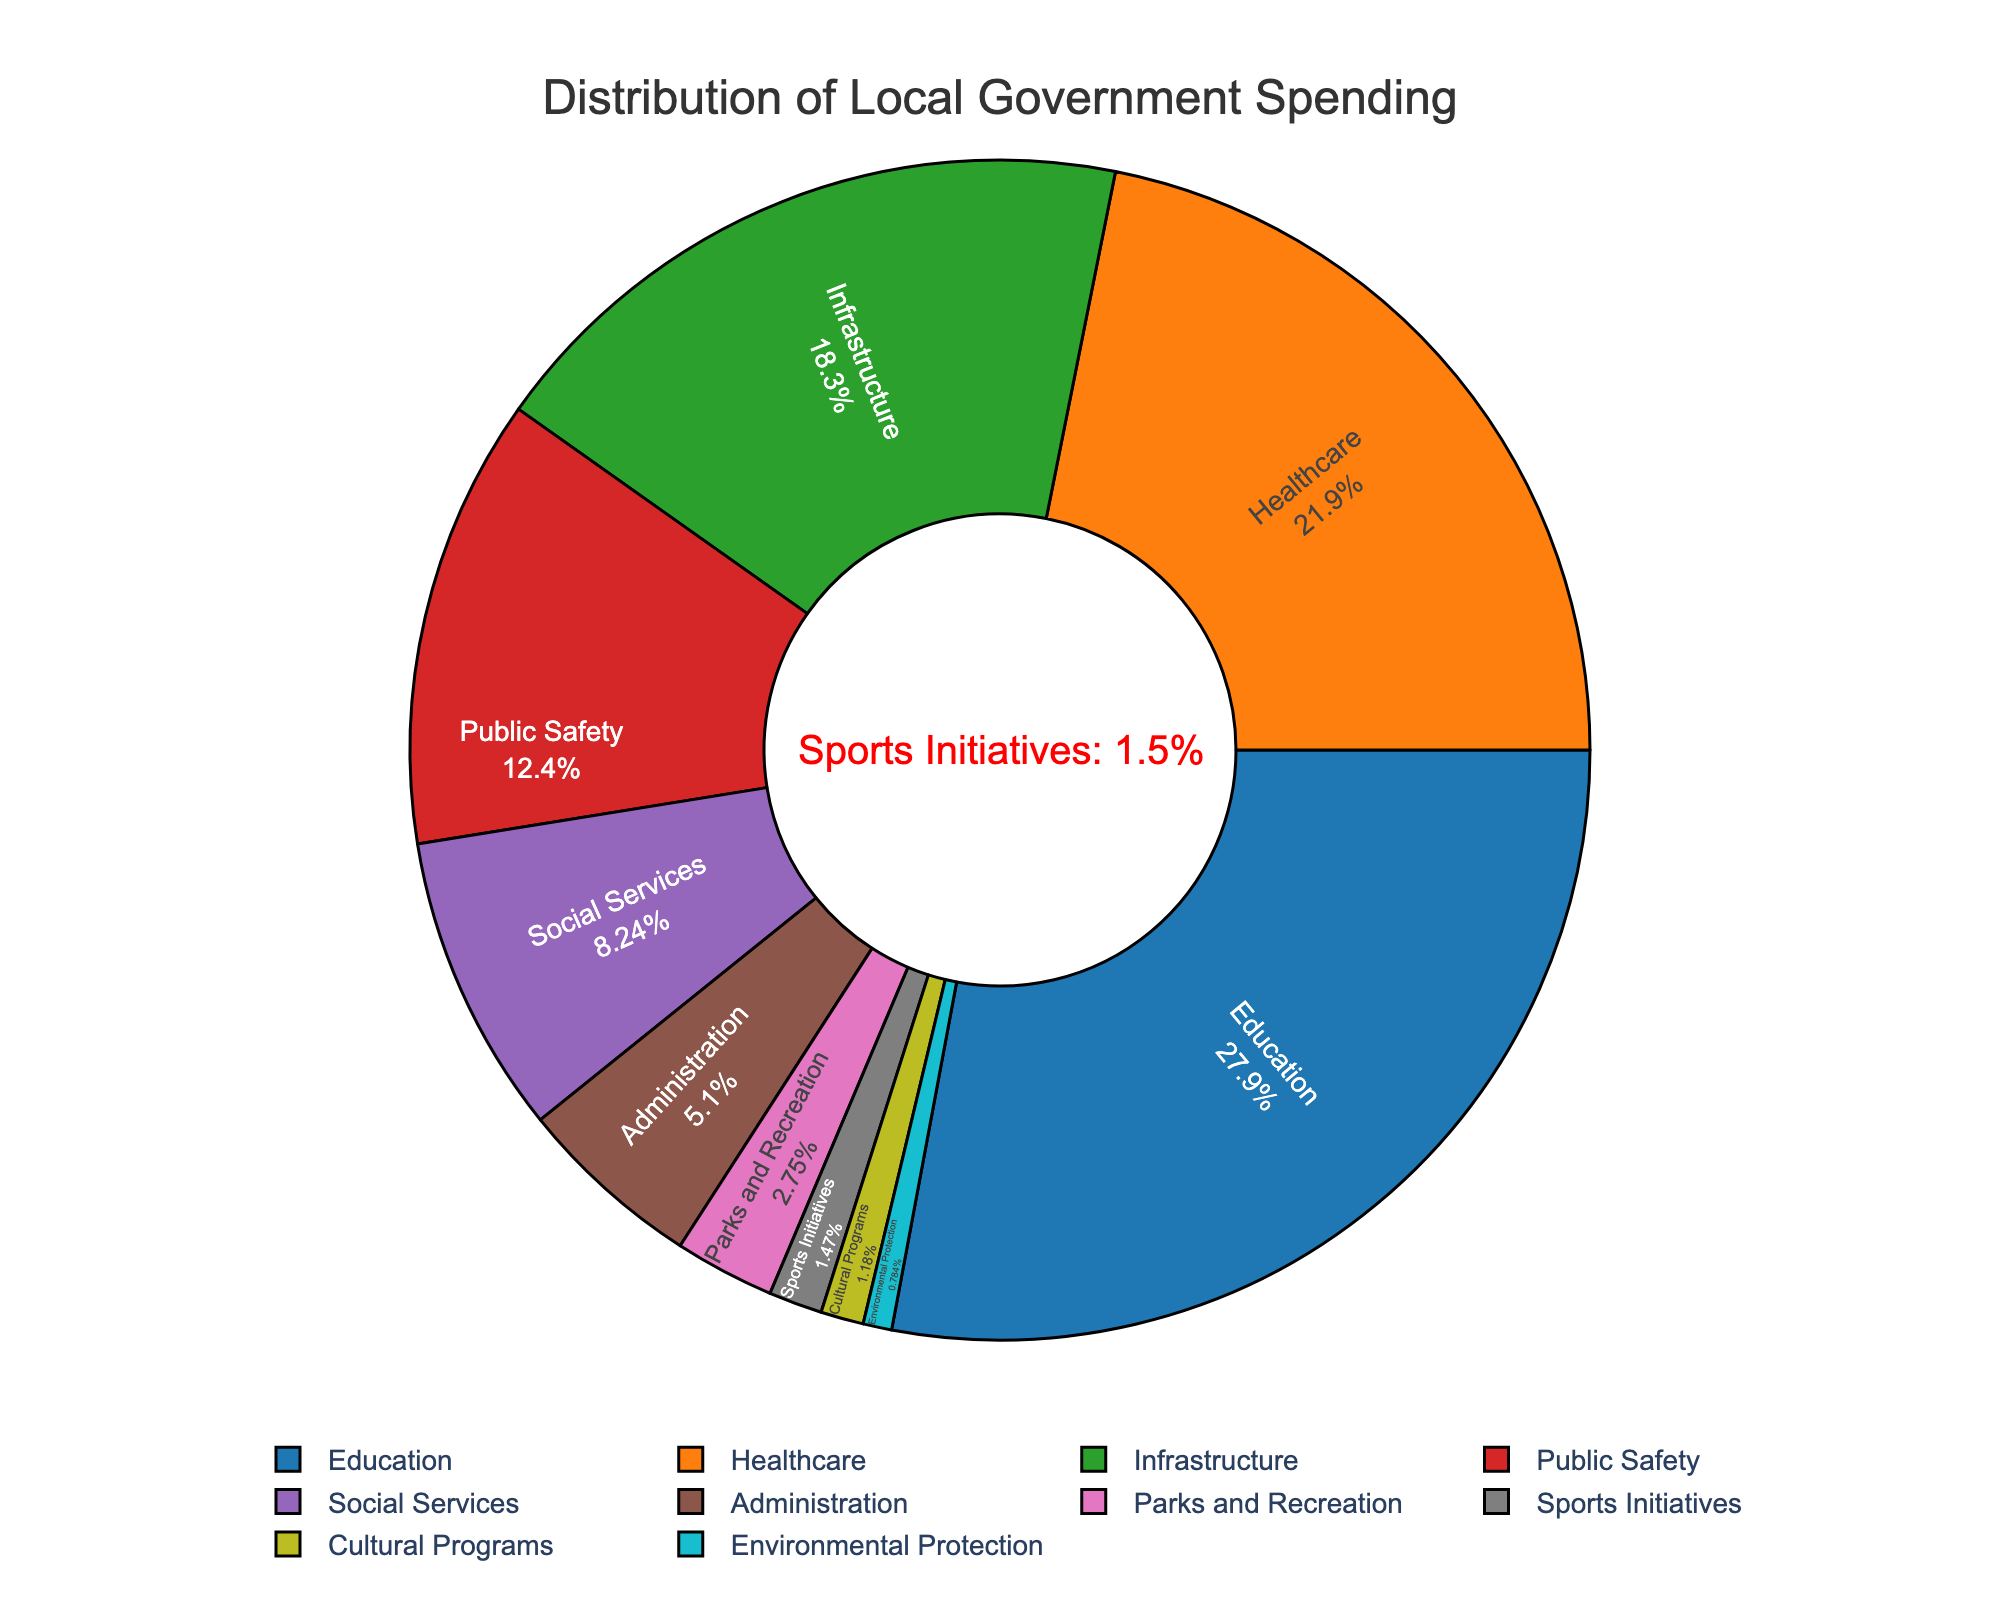What is the sector with the highest percentage of local government spending? The sector with the highest percentage can be identified by looking for the largest slice in the pie chart. Here, 'Education' has the largest slice with 28.5%.
Answer: Education (28.5%) What is the total percentage of local government spending on 'Healthcare' and 'Infrastructure'? Add the percentages for 'Healthcare' and 'Infrastructure', which are 22.3% and 18.7%, respectively. So, 22.3% + 18.7% = 41%.
Answer: 41% How does the investment in 'Sports Initiatives' compare to 'Parks and Recreation'? Compare the percentages directly from the chart. 'Sports Initiatives' is 1.5% and 'Parks and Recreation' is 2.8%. 'Parks and Recreation' receives a higher percentage than 'Sports Initiatives'.
Answer: 'Parks and Recreation' (2.8%) > 'Sports Initiatives' (1.5%) What is the combined percentage for sectors that have less than 5% of spending? Identify sectors with less than 5%: Administration (5.2%) is not included. Add the percentages for Sports Initiatives (1.5%), Cultural Programs (1.2%), and Environmental Protection (0.8%). So, 1.5% + 1.2% + 0.8% = 3.5%.
Answer: 3.5% Which sector receives the least amount of funding? The smallest slice in the pie chart represents the sector with the least funding. 'Environmental Protection' has the smallest slice with 0.8%.
Answer: Environmental Protection (0.8%) Is the spending on 'Public Safety' greater or lesser than that on 'Social Services'? Compare the percentages directly from the chart. 'Public Safety' is 12.6% and 'Social Services' is 8.4%. 'Public Safety' receives a higher percentage than 'Social Services'.
Answer: Greater (12.6% > 8.4%) What is the difference in spending percentage between 'Education' and 'Public Safety'? Subtract the percentage of 'Public Safety' from 'Education'. So, 28.5% - 12.6% = 15.9%.
Answer: 15.9% What is the average percentage for the top three sectors? Find the top three sectors: Education (28.5%), Healthcare (22.3%), and Infrastructure (18.7%). Calculate the average: (28.5% + 22.3% + 18.7%) / 3 ≈ 23.17%.
Answer: 23.17% What visual attribute differentiates 'Sports Initiatives' from 'Healthcare'? Aside from the percentages, 'Sports Initiatives' has a distinct color and is marked by a specific annotation in red on the figure mentioning it is 1.5%. 'Healthcare' is part of the larger segments and has a different color without such annotation.
Answer: Color and annotation Overall, what is the total percentage of spending on sectors related to public welfare (Education, Healthcare, Social Services)? Sum the percentages of Education (28.5%), Healthcare (22.3%), and Social Services (8.4%). So, 28.5% + 22.3% + 8.4% = 59.2%.
Answer: 59.2% 